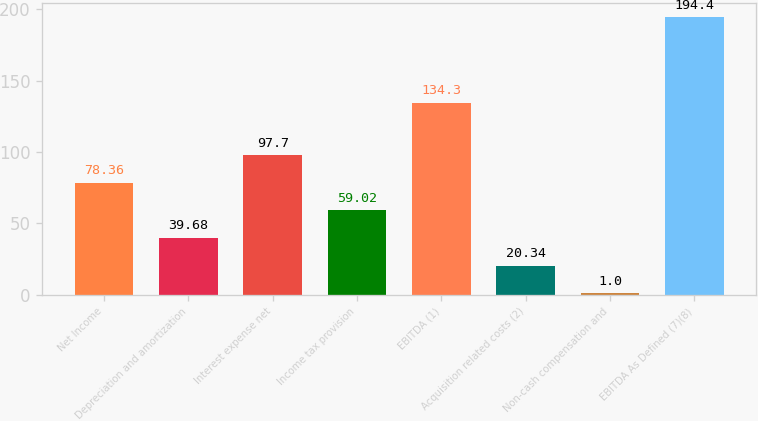Convert chart. <chart><loc_0><loc_0><loc_500><loc_500><bar_chart><fcel>Net Income<fcel>Depreciation and amortization<fcel>Interest expense net<fcel>Income tax provision<fcel>EBITDA (1)<fcel>Acquisition related costs (2)<fcel>Non-cash compensation and<fcel>EBITDA As Defined (7)(8)<nl><fcel>78.36<fcel>39.68<fcel>97.7<fcel>59.02<fcel>134.3<fcel>20.34<fcel>1<fcel>194.4<nl></chart> 